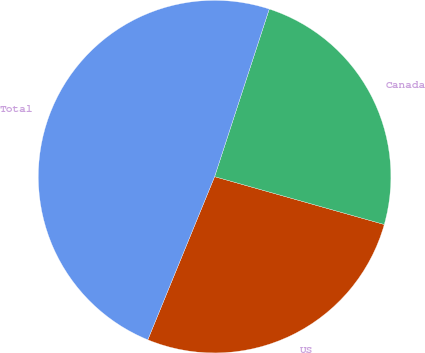Convert chart. <chart><loc_0><loc_0><loc_500><loc_500><pie_chart><fcel>US<fcel>Canada<fcel>Total<nl><fcel>26.81%<fcel>24.36%<fcel>48.83%<nl></chart> 